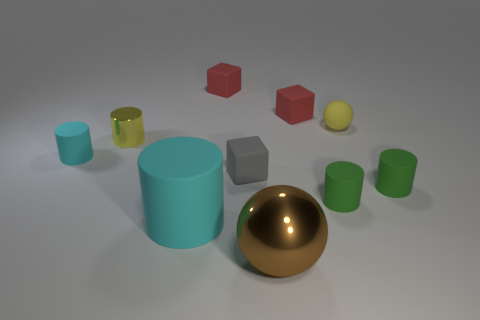Subtract all matte cylinders. How many cylinders are left? 1 Subtract all cyan cylinders. How many cylinders are left? 3 Subtract 5 cylinders. How many cylinders are left? 0 Subtract all brown balls. Subtract all yellow cylinders. How many balls are left? 1 Subtract all brown cylinders. How many yellow balls are left? 1 Subtract all tiny yellow rubber things. Subtract all tiny yellow cylinders. How many objects are left? 8 Add 6 matte cubes. How many matte cubes are left? 9 Add 9 big green shiny balls. How many big green shiny balls exist? 9 Subtract 1 gray cubes. How many objects are left? 9 Subtract all blocks. How many objects are left? 7 